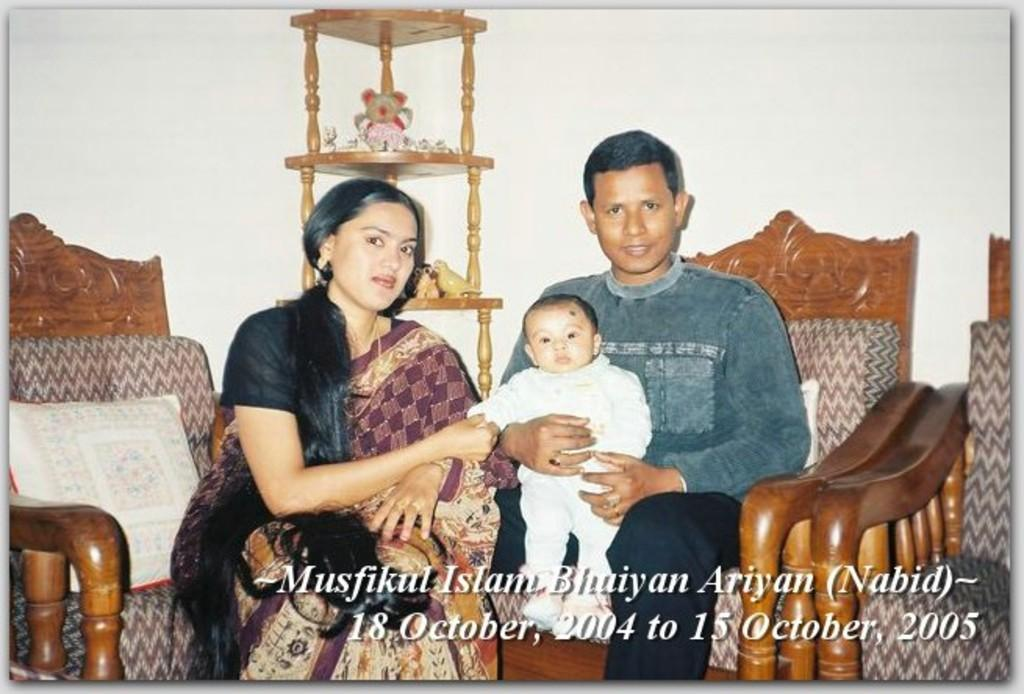What is the person in the image doing? The person is sitting on a chair and holding a baby in their hands. Who else is present in the image? There is a woman sitting beside the person holding the baby. What object is near the woman? There is a pillow near the woman. What can be seen in the background of the image? There is a wall visible in the background. What type of insect can be seen playing a musical instrument in the image? There is no insect or musical instrument present in the image. What color is the light illuminating the scene in the image? There is no mention of a light source in the image, so we cannot determine its color. 